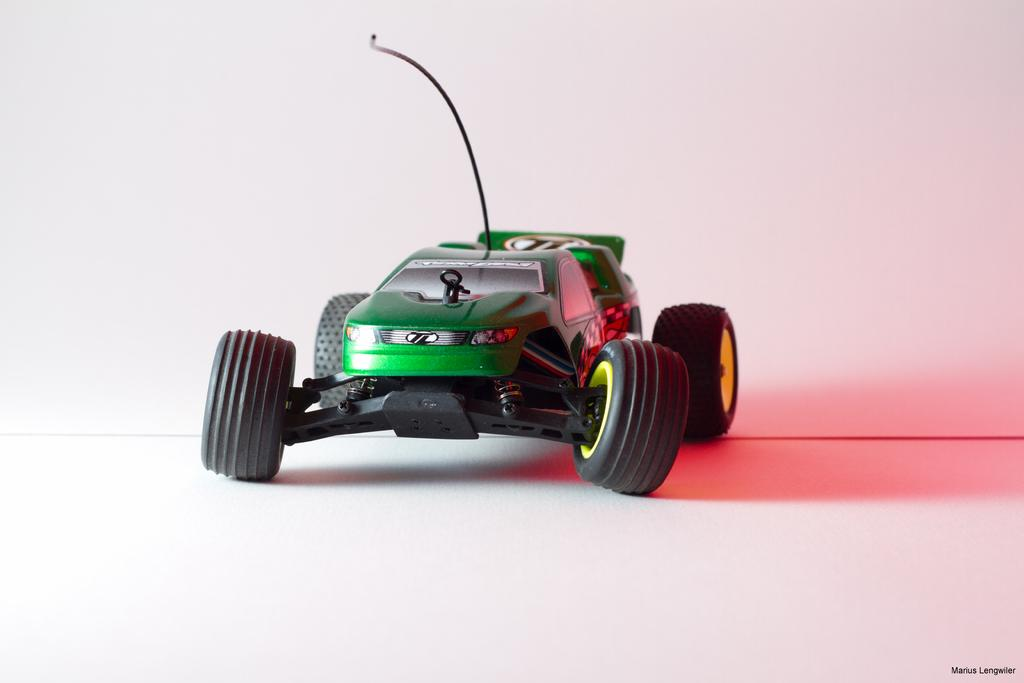What type of toy is in the image? There is a toy car in the image. What color is the toy car? The toy car is green in color. How many tires does the toy car have? The toy car has four tires. Where is the toy car located in the image? The toy car is placed on the floor. Is there anything connected to the toy car? Yes, there is a wire connected to the toy car. What is visible behind the toy car? There is a wall behind the toy car. How many bikes are parked next to the toy car in the image? There are no bikes present in the image; it only features a toy car. What type of drink is being served in the image? There is no drink present in the image; it only features a toy car. 